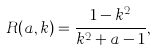<formula> <loc_0><loc_0><loc_500><loc_500>R ( a , k ) = \frac { 1 - k ^ { 2 } } { k ^ { 2 } + a - 1 } ,</formula> 